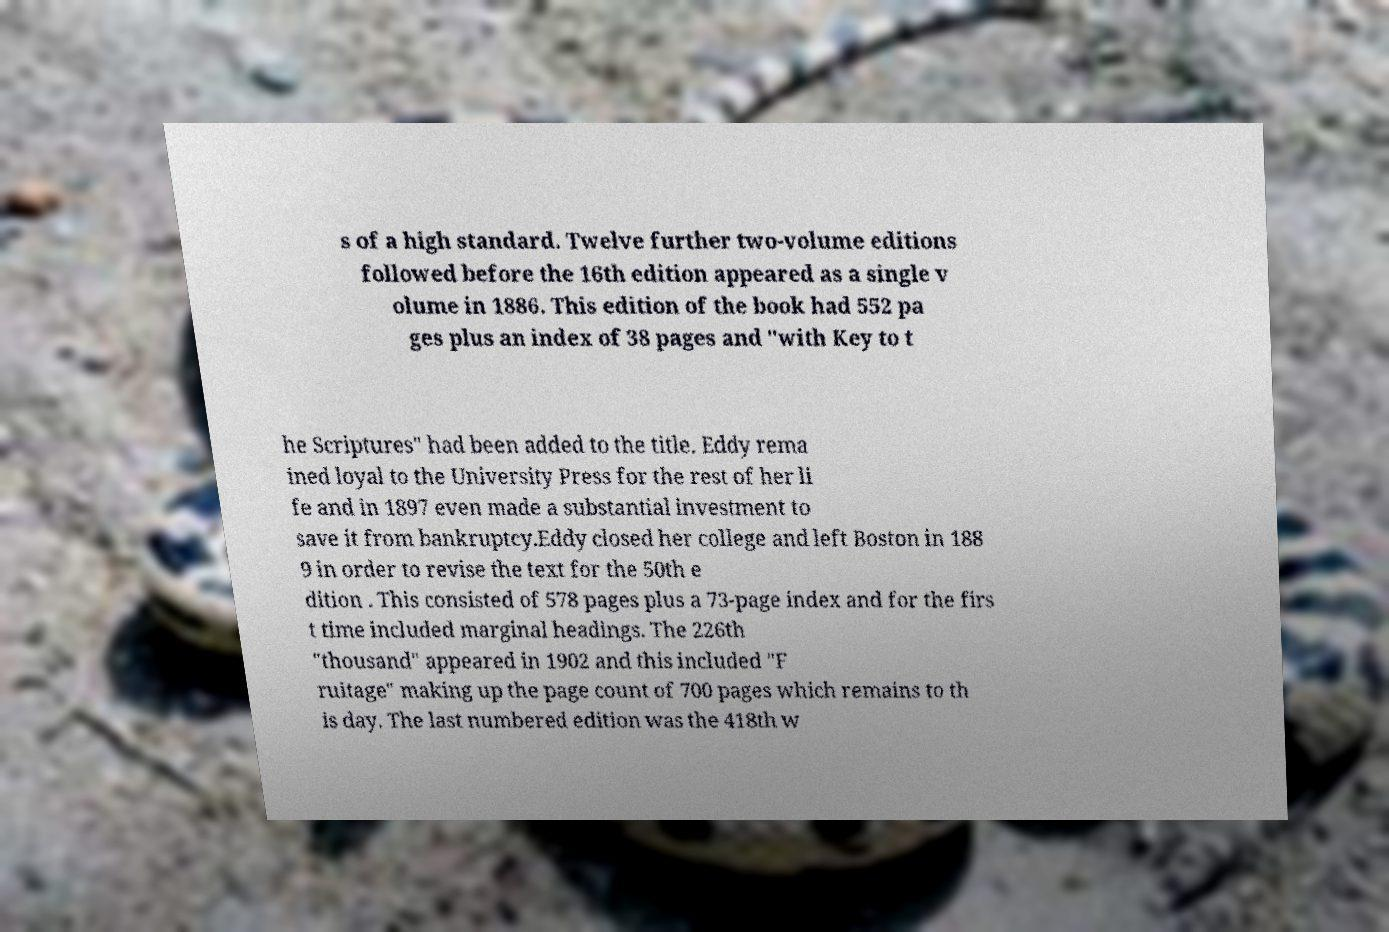What messages or text are displayed in this image? I need them in a readable, typed format. s of a high standard. Twelve further two-volume editions followed before the 16th edition appeared as a single v olume in 1886. This edition of the book had 552 pa ges plus an index of 38 pages and "with Key to t he Scriptures" had been added to the title. Eddy rema ined loyal to the University Press for the rest of her li fe and in 1897 even made a substantial investment to save it from bankruptcy.Eddy closed her college and left Boston in 188 9 in order to revise the text for the 50th e dition . This consisted of 578 pages plus a 73-page index and for the firs t time included marginal headings. The 226th "thousand" appeared in 1902 and this included "F ruitage" making up the page count of 700 pages which remains to th is day. The last numbered edition was the 418th w 